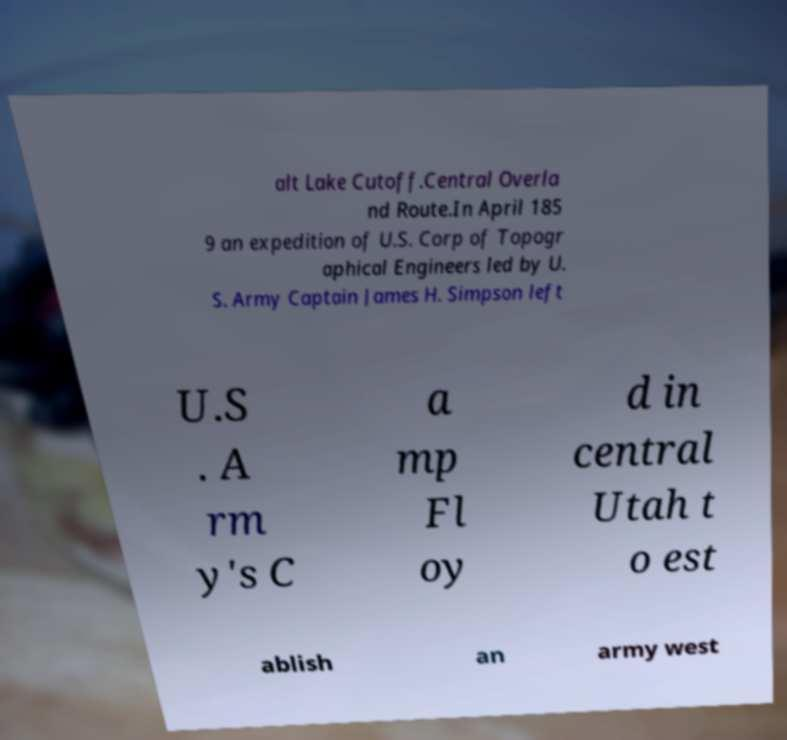Please identify and transcribe the text found in this image. alt Lake Cutoff.Central Overla nd Route.In April 185 9 an expedition of U.S. Corp of Topogr aphical Engineers led by U. S. Army Captain James H. Simpson left U.S . A rm y's C a mp Fl oy d in central Utah t o est ablish an army west 